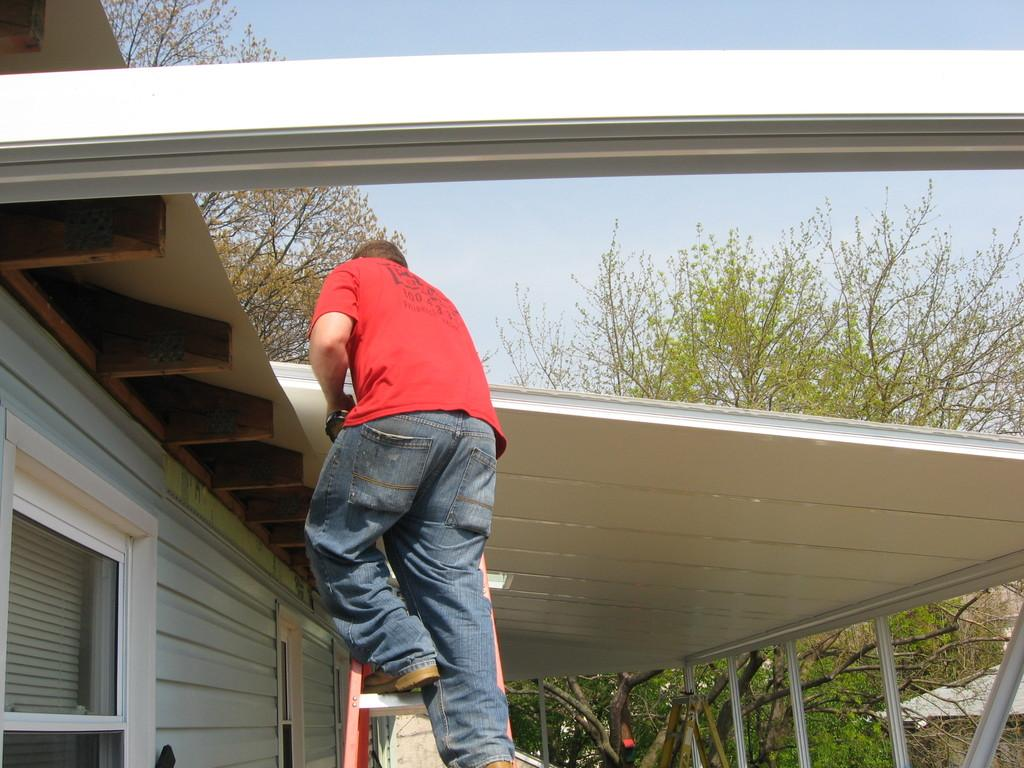Who is present in the image? There is a man in the image. What is the man wearing? The man is wearing a red t-shirt. What activity is the man engaged in? The man is climbing a ladder. What is above the man? There is a white roof top above the man. What can be seen in the background of the image? There are trees in the background of the image. What type of fish can be seen swimming in the jar in the image? There is no jar or fish present in the image. How many potatoes are visible on the man's red t-shirt in the image? There are no potatoes depicted on the man's red t-shirt in the image. 